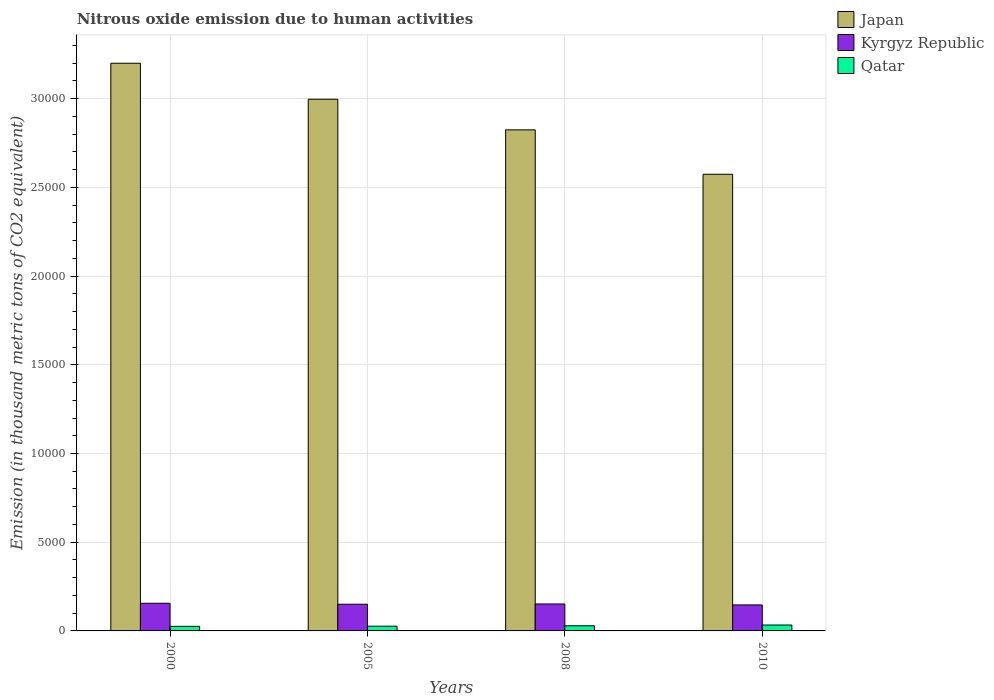How many groups of bars are there?
Offer a very short reply. 4. Are the number of bars on each tick of the X-axis equal?
Provide a succinct answer. Yes. What is the label of the 3rd group of bars from the left?
Ensure brevity in your answer.  2008. What is the amount of nitrous oxide emitted in Kyrgyz Republic in 2008?
Your response must be concise. 1519.3. Across all years, what is the maximum amount of nitrous oxide emitted in Qatar?
Provide a short and direct response. 332.4. Across all years, what is the minimum amount of nitrous oxide emitted in Kyrgyz Republic?
Your response must be concise. 1465. In which year was the amount of nitrous oxide emitted in Qatar maximum?
Offer a very short reply. 2010. What is the total amount of nitrous oxide emitted in Kyrgyz Republic in the graph?
Your response must be concise. 6047.7. What is the difference between the amount of nitrous oxide emitted in Qatar in 2005 and that in 2008?
Offer a terse response. -22.5. What is the difference between the amount of nitrous oxide emitted in Japan in 2010 and the amount of nitrous oxide emitted in Kyrgyz Republic in 2005?
Provide a short and direct response. 2.42e+04. What is the average amount of nitrous oxide emitted in Japan per year?
Give a very brief answer. 2.90e+04. In the year 2005, what is the difference between the amount of nitrous oxide emitted in Kyrgyz Republic and amount of nitrous oxide emitted in Qatar?
Your answer should be compact. 1236.7. In how many years, is the amount of nitrous oxide emitted in Qatar greater than 13000 thousand metric tons?
Keep it short and to the point. 0. What is the ratio of the amount of nitrous oxide emitted in Qatar in 2005 to that in 2008?
Your answer should be compact. 0.92. Is the amount of nitrous oxide emitted in Qatar in 2000 less than that in 2008?
Offer a very short reply. Yes. Is the difference between the amount of nitrous oxide emitted in Kyrgyz Republic in 2005 and 2008 greater than the difference between the amount of nitrous oxide emitted in Qatar in 2005 and 2008?
Keep it short and to the point. Yes. What is the difference between the highest and the second highest amount of nitrous oxide emitted in Japan?
Your response must be concise. 2027.5. What is the difference between the highest and the lowest amount of nitrous oxide emitted in Japan?
Your answer should be very brief. 6256.2. In how many years, is the amount of nitrous oxide emitted in Kyrgyz Republic greater than the average amount of nitrous oxide emitted in Kyrgyz Republic taken over all years?
Offer a very short reply. 2. Is the sum of the amount of nitrous oxide emitted in Qatar in 2000 and 2010 greater than the maximum amount of nitrous oxide emitted in Japan across all years?
Provide a succinct answer. No. What does the 2nd bar from the left in 2010 represents?
Your answer should be very brief. Kyrgyz Republic. How many years are there in the graph?
Give a very brief answer. 4. Does the graph contain grids?
Give a very brief answer. Yes. How are the legend labels stacked?
Ensure brevity in your answer.  Vertical. What is the title of the graph?
Ensure brevity in your answer.  Nitrous oxide emission due to human activities. Does "Low income" appear as one of the legend labels in the graph?
Your answer should be compact. No. What is the label or title of the X-axis?
Provide a short and direct response. Years. What is the label or title of the Y-axis?
Provide a succinct answer. Emission (in thousand metric tons of CO2 equivalent). What is the Emission (in thousand metric tons of CO2 equivalent) of Japan in 2000?
Give a very brief answer. 3.20e+04. What is the Emission (in thousand metric tons of CO2 equivalent) in Kyrgyz Republic in 2000?
Ensure brevity in your answer.  1559.1. What is the Emission (in thousand metric tons of CO2 equivalent) of Qatar in 2000?
Provide a short and direct response. 258.6. What is the Emission (in thousand metric tons of CO2 equivalent) in Japan in 2005?
Keep it short and to the point. 3.00e+04. What is the Emission (in thousand metric tons of CO2 equivalent) of Kyrgyz Republic in 2005?
Keep it short and to the point. 1504.3. What is the Emission (in thousand metric tons of CO2 equivalent) of Qatar in 2005?
Your response must be concise. 267.6. What is the Emission (in thousand metric tons of CO2 equivalent) in Japan in 2008?
Keep it short and to the point. 2.82e+04. What is the Emission (in thousand metric tons of CO2 equivalent) in Kyrgyz Republic in 2008?
Offer a terse response. 1519.3. What is the Emission (in thousand metric tons of CO2 equivalent) of Qatar in 2008?
Ensure brevity in your answer.  290.1. What is the Emission (in thousand metric tons of CO2 equivalent) of Japan in 2010?
Offer a very short reply. 2.57e+04. What is the Emission (in thousand metric tons of CO2 equivalent) of Kyrgyz Republic in 2010?
Your answer should be very brief. 1465. What is the Emission (in thousand metric tons of CO2 equivalent) in Qatar in 2010?
Give a very brief answer. 332.4. Across all years, what is the maximum Emission (in thousand metric tons of CO2 equivalent) in Japan?
Provide a short and direct response. 3.20e+04. Across all years, what is the maximum Emission (in thousand metric tons of CO2 equivalent) in Kyrgyz Republic?
Your response must be concise. 1559.1. Across all years, what is the maximum Emission (in thousand metric tons of CO2 equivalent) in Qatar?
Your answer should be very brief. 332.4. Across all years, what is the minimum Emission (in thousand metric tons of CO2 equivalent) in Japan?
Your response must be concise. 2.57e+04. Across all years, what is the minimum Emission (in thousand metric tons of CO2 equivalent) in Kyrgyz Republic?
Your response must be concise. 1465. Across all years, what is the minimum Emission (in thousand metric tons of CO2 equivalent) of Qatar?
Your answer should be very brief. 258.6. What is the total Emission (in thousand metric tons of CO2 equivalent) of Japan in the graph?
Your answer should be very brief. 1.16e+05. What is the total Emission (in thousand metric tons of CO2 equivalent) of Kyrgyz Republic in the graph?
Your response must be concise. 6047.7. What is the total Emission (in thousand metric tons of CO2 equivalent) of Qatar in the graph?
Offer a terse response. 1148.7. What is the difference between the Emission (in thousand metric tons of CO2 equivalent) of Japan in 2000 and that in 2005?
Keep it short and to the point. 2027.5. What is the difference between the Emission (in thousand metric tons of CO2 equivalent) in Kyrgyz Republic in 2000 and that in 2005?
Your answer should be very brief. 54.8. What is the difference between the Emission (in thousand metric tons of CO2 equivalent) of Qatar in 2000 and that in 2005?
Give a very brief answer. -9. What is the difference between the Emission (in thousand metric tons of CO2 equivalent) in Japan in 2000 and that in 2008?
Your answer should be very brief. 3753.1. What is the difference between the Emission (in thousand metric tons of CO2 equivalent) of Kyrgyz Republic in 2000 and that in 2008?
Offer a terse response. 39.8. What is the difference between the Emission (in thousand metric tons of CO2 equivalent) in Qatar in 2000 and that in 2008?
Provide a short and direct response. -31.5. What is the difference between the Emission (in thousand metric tons of CO2 equivalent) of Japan in 2000 and that in 2010?
Keep it short and to the point. 6256.2. What is the difference between the Emission (in thousand metric tons of CO2 equivalent) in Kyrgyz Republic in 2000 and that in 2010?
Give a very brief answer. 94.1. What is the difference between the Emission (in thousand metric tons of CO2 equivalent) in Qatar in 2000 and that in 2010?
Your response must be concise. -73.8. What is the difference between the Emission (in thousand metric tons of CO2 equivalent) of Japan in 2005 and that in 2008?
Give a very brief answer. 1725.6. What is the difference between the Emission (in thousand metric tons of CO2 equivalent) in Kyrgyz Republic in 2005 and that in 2008?
Offer a terse response. -15. What is the difference between the Emission (in thousand metric tons of CO2 equivalent) of Qatar in 2005 and that in 2008?
Ensure brevity in your answer.  -22.5. What is the difference between the Emission (in thousand metric tons of CO2 equivalent) of Japan in 2005 and that in 2010?
Your answer should be very brief. 4228.7. What is the difference between the Emission (in thousand metric tons of CO2 equivalent) in Kyrgyz Republic in 2005 and that in 2010?
Give a very brief answer. 39.3. What is the difference between the Emission (in thousand metric tons of CO2 equivalent) in Qatar in 2005 and that in 2010?
Give a very brief answer. -64.8. What is the difference between the Emission (in thousand metric tons of CO2 equivalent) of Japan in 2008 and that in 2010?
Provide a short and direct response. 2503.1. What is the difference between the Emission (in thousand metric tons of CO2 equivalent) of Kyrgyz Republic in 2008 and that in 2010?
Make the answer very short. 54.3. What is the difference between the Emission (in thousand metric tons of CO2 equivalent) of Qatar in 2008 and that in 2010?
Make the answer very short. -42.3. What is the difference between the Emission (in thousand metric tons of CO2 equivalent) in Japan in 2000 and the Emission (in thousand metric tons of CO2 equivalent) in Kyrgyz Republic in 2005?
Keep it short and to the point. 3.05e+04. What is the difference between the Emission (in thousand metric tons of CO2 equivalent) in Japan in 2000 and the Emission (in thousand metric tons of CO2 equivalent) in Qatar in 2005?
Ensure brevity in your answer.  3.17e+04. What is the difference between the Emission (in thousand metric tons of CO2 equivalent) of Kyrgyz Republic in 2000 and the Emission (in thousand metric tons of CO2 equivalent) of Qatar in 2005?
Provide a short and direct response. 1291.5. What is the difference between the Emission (in thousand metric tons of CO2 equivalent) of Japan in 2000 and the Emission (in thousand metric tons of CO2 equivalent) of Kyrgyz Republic in 2008?
Ensure brevity in your answer.  3.05e+04. What is the difference between the Emission (in thousand metric tons of CO2 equivalent) of Japan in 2000 and the Emission (in thousand metric tons of CO2 equivalent) of Qatar in 2008?
Ensure brevity in your answer.  3.17e+04. What is the difference between the Emission (in thousand metric tons of CO2 equivalent) in Kyrgyz Republic in 2000 and the Emission (in thousand metric tons of CO2 equivalent) in Qatar in 2008?
Offer a terse response. 1269. What is the difference between the Emission (in thousand metric tons of CO2 equivalent) of Japan in 2000 and the Emission (in thousand metric tons of CO2 equivalent) of Kyrgyz Republic in 2010?
Provide a succinct answer. 3.05e+04. What is the difference between the Emission (in thousand metric tons of CO2 equivalent) of Japan in 2000 and the Emission (in thousand metric tons of CO2 equivalent) of Qatar in 2010?
Provide a short and direct response. 3.17e+04. What is the difference between the Emission (in thousand metric tons of CO2 equivalent) of Kyrgyz Republic in 2000 and the Emission (in thousand metric tons of CO2 equivalent) of Qatar in 2010?
Offer a very short reply. 1226.7. What is the difference between the Emission (in thousand metric tons of CO2 equivalent) in Japan in 2005 and the Emission (in thousand metric tons of CO2 equivalent) in Kyrgyz Republic in 2008?
Offer a very short reply. 2.84e+04. What is the difference between the Emission (in thousand metric tons of CO2 equivalent) of Japan in 2005 and the Emission (in thousand metric tons of CO2 equivalent) of Qatar in 2008?
Your response must be concise. 2.97e+04. What is the difference between the Emission (in thousand metric tons of CO2 equivalent) in Kyrgyz Republic in 2005 and the Emission (in thousand metric tons of CO2 equivalent) in Qatar in 2008?
Offer a very short reply. 1214.2. What is the difference between the Emission (in thousand metric tons of CO2 equivalent) of Japan in 2005 and the Emission (in thousand metric tons of CO2 equivalent) of Kyrgyz Republic in 2010?
Ensure brevity in your answer.  2.85e+04. What is the difference between the Emission (in thousand metric tons of CO2 equivalent) in Japan in 2005 and the Emission (in thousand metric tons of CO2 equivalent) in Qatar in 2010?
Your answer should be compact. 2.96e+04. What is the difference between the Emission (in thousand metric tons of CO2 equivalent) in Kyrgyz Republic in 2005 and the Emission (in thousand metric tons of CO2 equivalent) in Qatar in 2010?
Offer a very short reply. 1171.9. What is the difference between the Emission (in thousand metric tons of CO2 equivalent) in Japan in 2008 and the Emission (in thousand metric tons of CO2 equivalent) in Kyrgyz Republic in 2010?
Your answer should be compact. 2.68e+04. What is the difference between the Emission (in thousand metric tons of CO2 equivalent) of Japan in 2008 and the Emission (in thousand metric tons of CO2 equivalent) of Qatar in 2010?
Your answer should be compact. 2.79e+04. What is the difference between the Emission (in thousand metric tons of CO2 equivalent) of Kyrgyz Republic in 2008 and the Emission (in thousand metric tons of CO2 equivalent) of Qatar in 2010?
Your answer should be very brief. 1186.9. What is the average Emission (in thousand metric tons of CO2 equivalent) of Japan per year?
Offer a very short reply. 2.90e+04. What is the average Emission (in thousand metric tons of CO2 equivalent) in Kyrgyz Republic per year?
Your response must be concise. 1511.92. What is the average Emission (in thousand metric tons of CO2 equivalent) of Qatar per year?
Keep it short and to the point. 287.18. In the year 2000, what is the difference between the Emission (in thousand metric tons of CO2 equivalent) in Japan and Emission (in thousand metric tons of CO2 equivalent) in Kyrgyz Republic?
Offer a very short reply. 3.04e+04. In the year 2000, what is the difference between the Emission (in thousand metric tons of CO2 equivalent) in Japan and Emission (in thousand metric tons of CO2 equivalent) in Qatar?
Give a very brief answer. 3.17e+04. In the year 2000, what is the difference between the Emission (in thousand metric tons of CO2 equivalent) of Kyrgyz Republic and Emission (in thousand metric tons of CO2 equivalent) of Qatar?
Offer a very short reply. 1300.5. In the year 2005, what is the difference between the Emission (in thousand metric tons of CO2 equivalent) in Japan and Emission (in thousand metric tons of CO2 equivalent) in Kyrgyz Republic?
Provide a succinct answer. 2.85e+04. In the year 2005, what is the difference between the Emission (in thousand metric tons of CO2 equivalent) of Japan and Emission (in thousand metric tons of CO2 equivalent) of Qatar?
Keep it short and to the point. 2.97e+04. In the year 2005, what is the difference between the Emission (in thousand metric tons of CO2 equivalent) of Kyrgyz Republic and Emission (in thousand metric tons of CO2 equivalent) of Qatar?
Offer a very short reply. 1236.7. In the year 2008, what is the difference between the Emission (in thousand metric tons of CO2 equivalent) of Japan and Emission (in thousand metric tons of CO2 equivalent) of Kyrgyz Republic?
Your answer should be very brief. 2.67e+04. In the year 2008, what is the difference between the Emission (in thousand metric tons of CO2 equivalent) in Japan and Emission (in thousand metric tons of CO2 equivalent) in Qatar?
Offer a terse response. 2.80e+04. In the year 2008, what is the difference between the Emission (in thousand metric tons of CO2 equivalent) in Kyrgyz Republic and Emission (in thousand metric tons of CO2 equivalent) in Qatar?
Offer a very short reply. 1229.2. In the year 2010, what is the difference between the Emission (in thousand metric tons of CO2 equivalent) of Japan and Emission (in thousand metric tons of CO2 equivalent) of Kyrgyz Republic?
Provide a short and direct response. 2.43e+04. In the year 2010, what is the difference between the Emission (in thousand metric tons of CO2 equivalent) in Japan and Emission (in thousand metric tons of CO2 equivalent) in Qatar?
Provide a succinct answer. 2.54e+04. In the year 2010, what is the difference between the Emission (in thousand metric tons of CO2 equivalent) in Kyrgyz Republic and Emission (in thousand metric tons of CO2 equivalent) in Qatar?
Give a very brief answer. 1132.6. What is the ratio of the Emission (in thousand metric tons of CO2 equivalent) in Japan in 2000 to that in 2005?
Make the answer very short. 1.07. What is the ratio of the Emission (in thousand metric tons of CO2 equivalent) of Kyrgyz Republic in 2000 to that in 2005?
Your response must be concise. 1.04. What is the ratio of the Emission (in thousand metric tons of CO2 equivalent) in Qatar in 2000 to that in 2005?
Provide a succinct answer. 0.97. What is the ratio of the Emission (in thousand metric tons of CO2 equivalent) in Japan in 2000 to that in 2008?
Give a very brief answer. 1.13. What is the ratio of the Emission (in thousand metric tons of CO2 equivalent) of Kyrgyz Republic in 2000 to that in 2008?
Ensure brevity in your answer.  1.03. What is the ratio of the Emission (in thousand metric tons of CO2 equivalent) in Qatar in 2000 to that in 2008?
Give a very brief answer. 0.89. What is the ratio of the Emission (in thousand metric tons of CO2 equivalent) of Japan in 2000 to that in 2010?
Offer a terse response. 1.24. What is the ratio of the Emission (in thousand metric tons of CO2 equivalent) of Kyrgyz Republic in 2000 to that in 2010?
Ensure brevity in your answer.  1.06. What is the ratio of the Emission (in thousand metric tons of CO2 equivalent) of Qatar in 2000 to that in 2010?
Offer a very short reply. 0.78. What is the ratio of the Emission (in thousand metric tons of CO2 equivalent) in Japan in 2005 to that in 2008?
Offer a very short reply. 1.06. What is the ratio of the Emission (in thousand metric tons of CO2 equivalent) of Qatar in 2005 to that in 2008?
Offer a terse response. 0.92. What is the ratio of the Emission (in thousand metric tons of CO2 equivalent) of Japan in 2005 to that in 2010?
Your answer should be very brief. 1.16. What is the ratio of the Emission (in thousand metric tons of CO2 equivalent) in Kyrgyz Republic in 2005 to that in 2010?
Your answer should be compact. 1.03. What is the ratio of the Emission (in thousand metric tons of CO2 equivalent) in Qatar in 2005 to that in 2010?
Your response must be concise. 0.81. What is the ratio of the Emission (in thousand metric tons of CO2 equivalent) of Japan in 2008 to that in 2010?
Your response must be concise. 1.1. What is the ratio of the Emission (in thousand metric tons of CO2 equivalent) in Kyrgyz Republic in 2008 to that in 2010?
Offer a terse response. 1.04. What is the ratio of the Emission (in thousand metric tons of CO2 equivalent) of Qatar in 2008 to that in 2010?
Keep it short and to the point. 0.87. What is the difference between the highest and the second highest Emission (in thousand metric tons of CO2 equivalent) of Japan?
Give a very brief answer. 2027.5. What is the difference between the highest and the second highest Emission (in thousand metric tons of CO2 equivalent) in Kyrgyz Republic?
Your answer should be compact. 39.8. What is the difference between the highest and the second highest Emission (in thousand metric tons of CO2 equivalent) of Qatar?
Provide a short and direct response. 42.3. What is the difference between the highest and the lowest Emission (in thousand metric tons of CO2 equivalent) of Japan?
Your answer should be very brief. 6256.2. What is the difference between the highest and the lowest Emission (in thousand metric tons of CO2 equivalent) of Kyrgyz Republic?
Offer a very short reply. 94.1. What is the difference between the highest and the lowest Emission (in thousand metric tons of CO2 equivalent) in Qatar?
Provide a short and direct response. 73.8. 